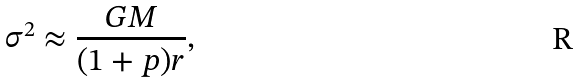Convert formula to latex. <formula><loc_0><loc_0><loc_500><loc_500>\sigma ^ { 2 } \approx \frac { G M } { ( 1 + p ) r } ,</formula> 